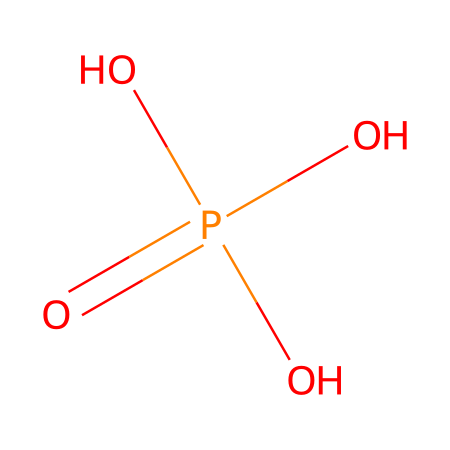How many oxygen atoms are present in the chemical structure? The SMILES representation features the notation "O" for oxygen. Counting the O's in "O=P(O)(O)O", there are four oxygen atoms in total.
Answer: four What is the central atom of this chemical structure? In the given SMILES, "P" represents phosphorus, which is located before the equals sign, indicating it is the central atom bonded to other groups.
Answer: phosphorus How many total valence electrons does the chemical have? Phosphorus has 5 valence electrons, and each oxygen has 6, accounting for a total of 29 valence electrons from 4 oxygens and 1 phosphorus (5 + 6*4 = 29).
Answer: twenty-nine What type of bonding is indicated by the '=' symbol in this structure? The '=' in "O=P" indicates a double bond between phosphorus and the first oxygen atom, representing the strong covalent bond formed in the structure.
Answer: double bond What functional groups can be identified in this chemical? The presence of three hydroxyl (-OH) groups as part of the oxygen atoms indicates it contains alcohol functional groups, which contribute to its properties.
Answer: alcohol Is this compound likely to be water-soluble? The presence of -OH groups suggests that the compound can interact favorably with water molecules, which usually indicates good water solubility.
Answer: yes What is the main use of this compound in photography? Due to its cleaning properties and ability to remove residues without damaging equipment, this compound is commonly used for cleaning camera lenses and other photography equipment.
Answer: cleaning agent 